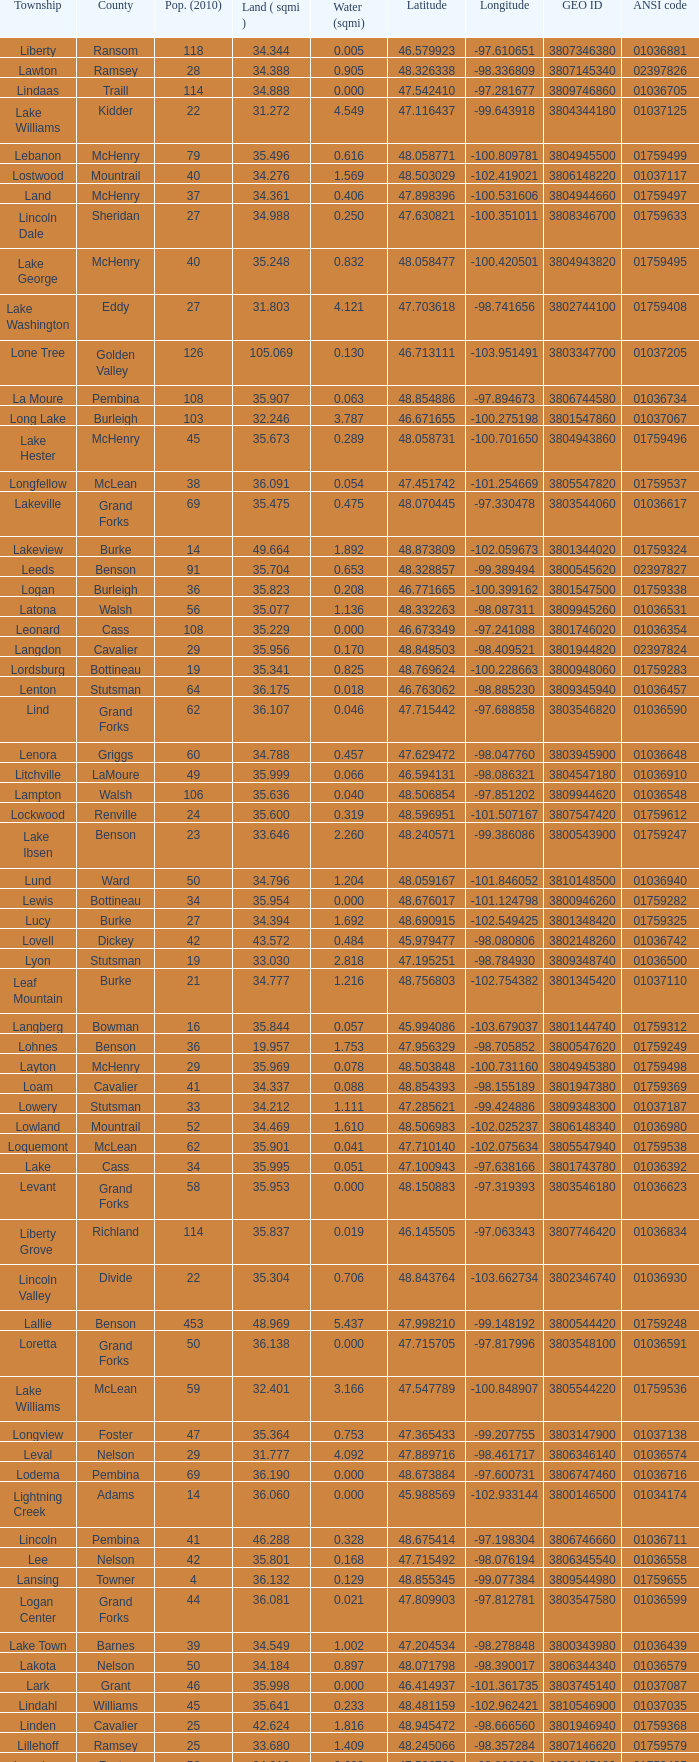What is latitude when 2010 population is 24 and water is more than 0.319? None. 